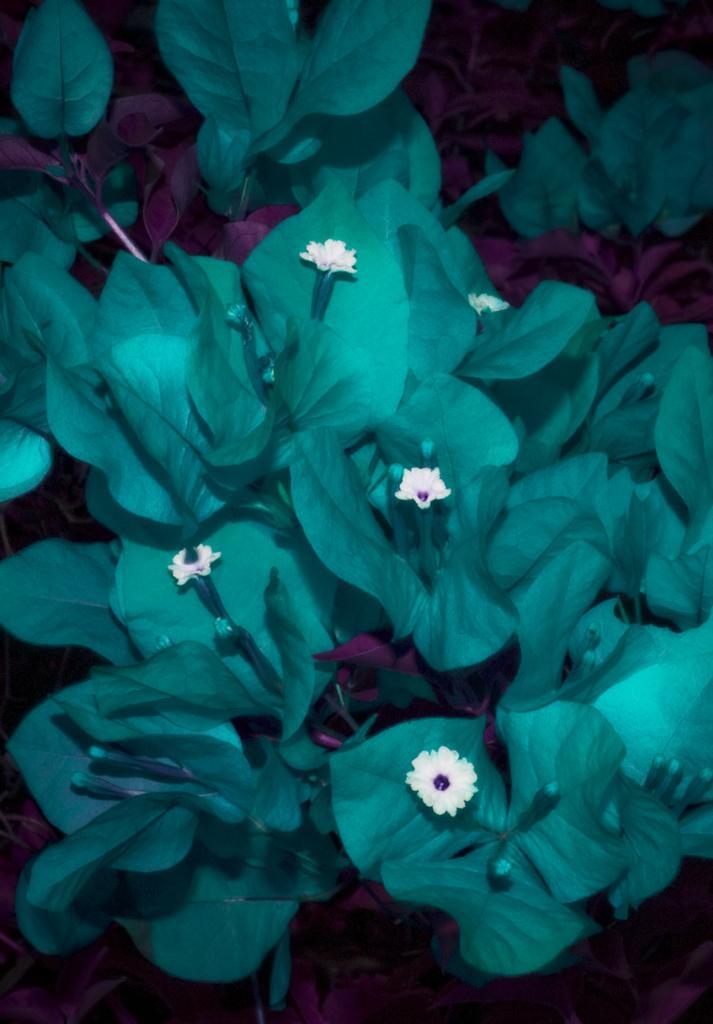Can you describe this image briefly? In this image I can see the white color flowers to the plant. I can see the plants are in green and pink color. 